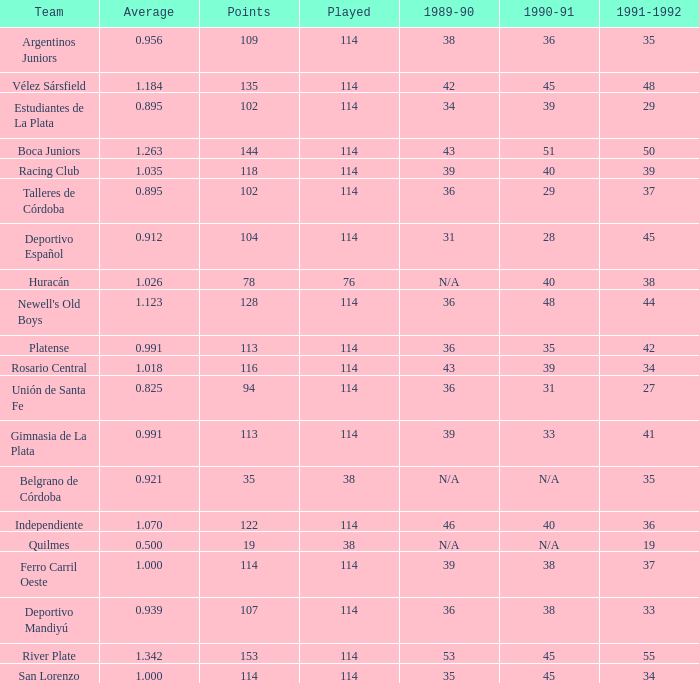Would you mind parsing the complete table? {'header': ['Team', 'Average', 'Points', 'Played', '1989-90', '1990-91', '1991-1992'], 'rows': [['Argentinos Juniors', '0.956', '109', '114', '38', '36', '35'], ['Vélez Sársfield', '1.184', '135', '114', '42', '45', '48'], ['Estudiantes de La Plata', '0.895', '102', '114', '34', '39', '29'], ['Boca Juniors', '1.263', '144', '114', '43', '51', '50'], ['Racing Club', '1.035', '118', '114', '39', '40', '39'], ['Talleres de Córdoba', '0.895', '102', '114', '36', '29', '37'], ['Deportivo Español', '0.912', '104', '114', '31', '28', '45'], ['Huracán', '1.026', '78', '76', 'N/A', '40', '38'], ["Newell's Old Boys", '1.123', '128', '114', '36', '48', '44'], ['Platense', '0.991', '113', '114', '36', '35', '42'], ['Rosario Central', '1.018', '116', '114', '43', '39', '34'], ['Unión de Santa Fe', '0.825', '94', '114', '36', '31', '27'], ['Gimnasia de La Plata', '0.991', '113', '114', '39', '33', '41'], ['Belgrano de Córdoba', '0.921', '35', '38', 'N/A', 'N/A', '35'], ['Independiente', '1.070', '122', '114', '46', '40', '36'], ['Quilmes', '0.500', '19', '38', 'N/A', 'N/A', '19'], ['Ferro Carril Oeste', '1.000', '114', '114', '39', '38', '37'], ['Deportivo Mandiyú', '0.939', '107', '114', '36', '38', '33'], ['River Plate', '1.342', '153', '114', '53', '45', '55'], ['San Lorenzo', '1.000', '114', '114', '35', '45', '34']]} How much Played has an Average smaller than 0.9390000000000001, and a 1990-91 of 28? 1.0. 